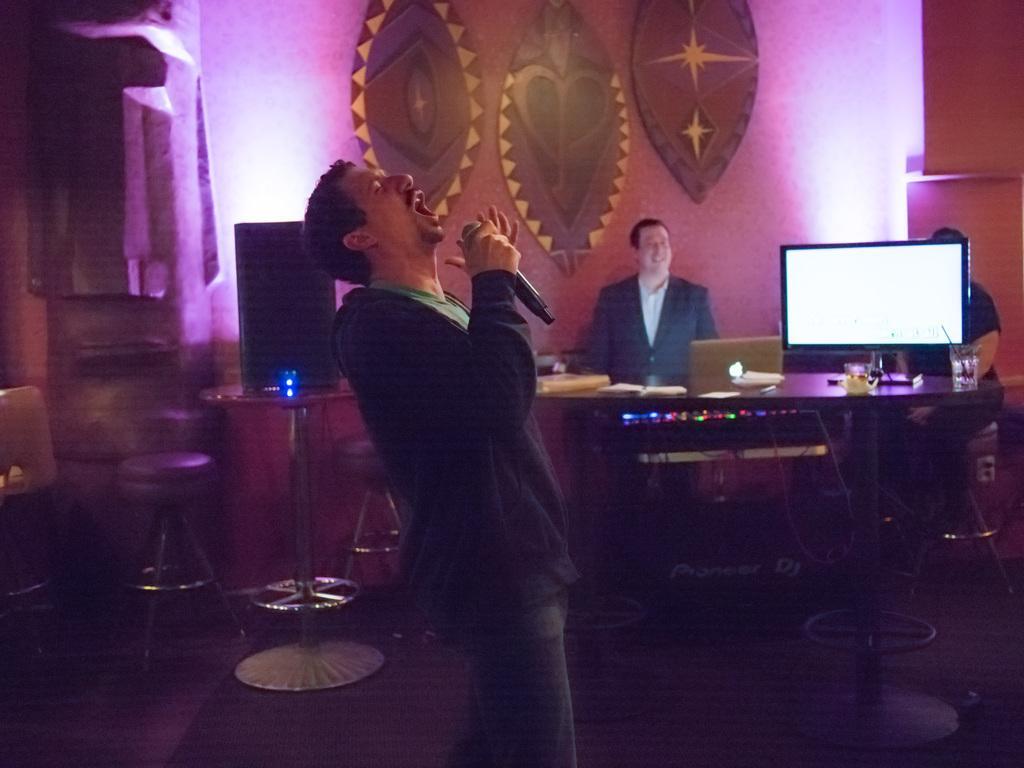How would you summarize this image in a sentence or two? In the image there is a man standing and singing a song, behind him there are chairs, speakers, a monitor and behind the monitor there are two other people. In the background there is a wall and there are some objects attached to the wall. 